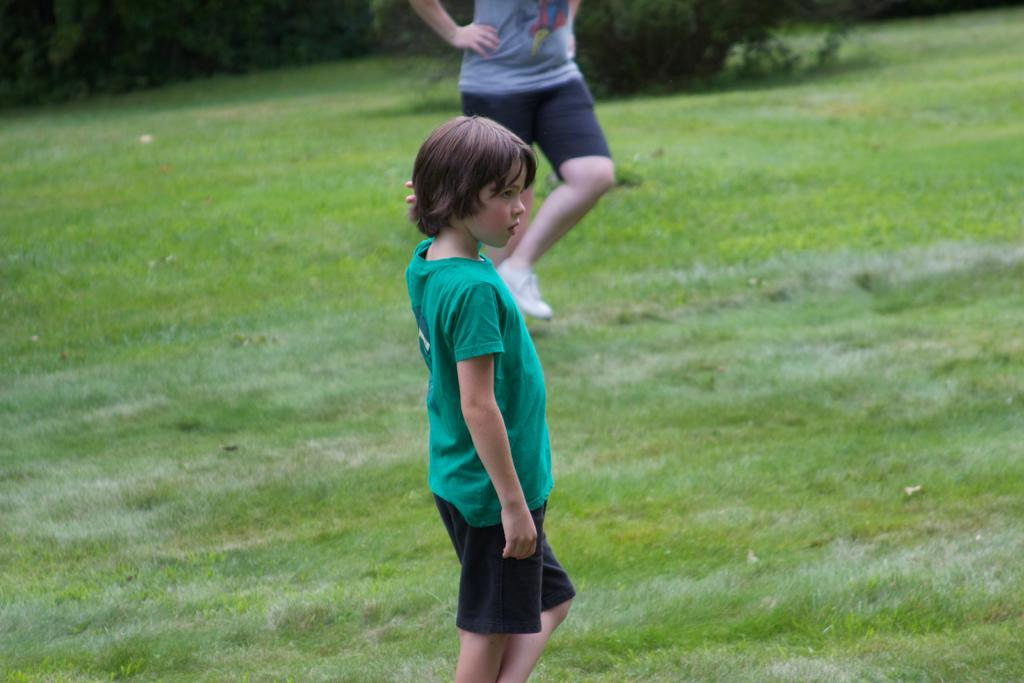Describe this image in one or two sentences. A person is standing on the grass wearing a green t shirt and black shorts. Behind him there is another person. There are trees at the back. 